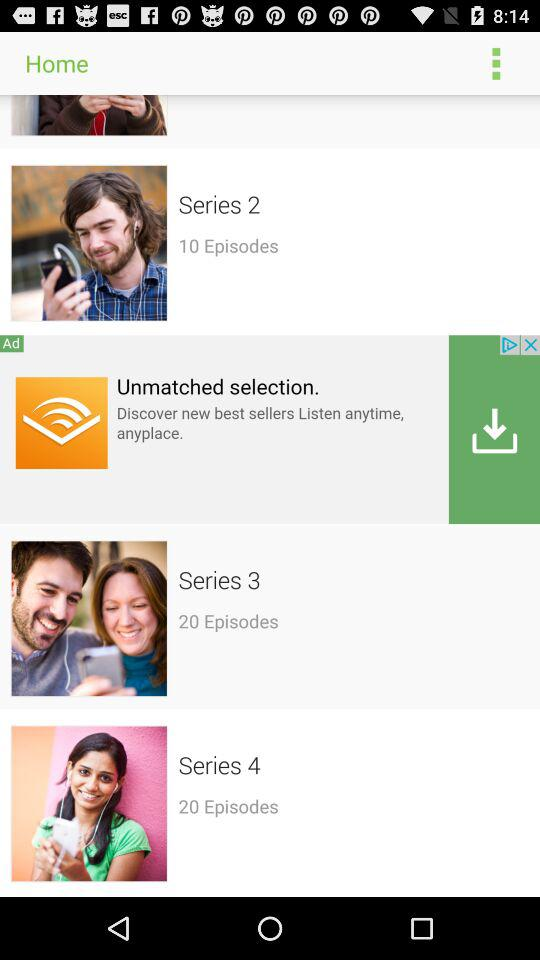How many episodes are in all of the series combined?
Answer the question using a single word or phrase. 50 